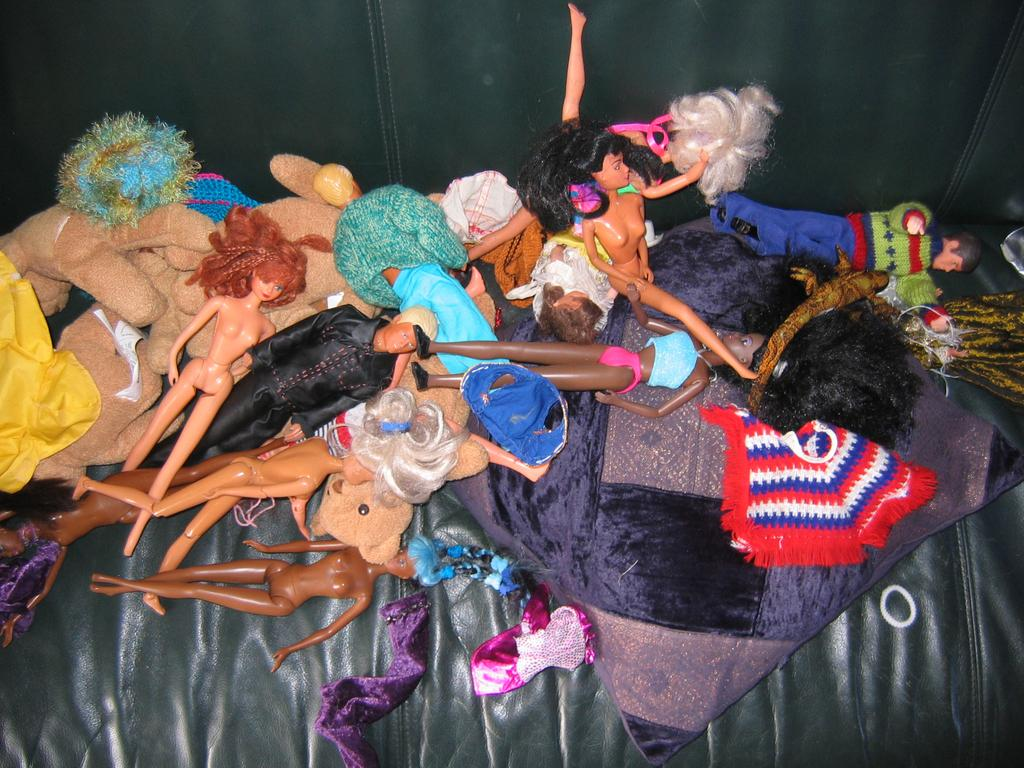What is present in the image in large quantities? There are many toys in the image. How do the toys differ from each other? The toys come in different colors and shapes. Where are the toys located in the image? The toys are kept on the sofa. What else can be seen on the sofa in the image? There is a pillow on the sofa. What type of insect can be seen crawling on the toys in the image? There are no insects present in the image; it only features toys and a pillow on the sofa. 